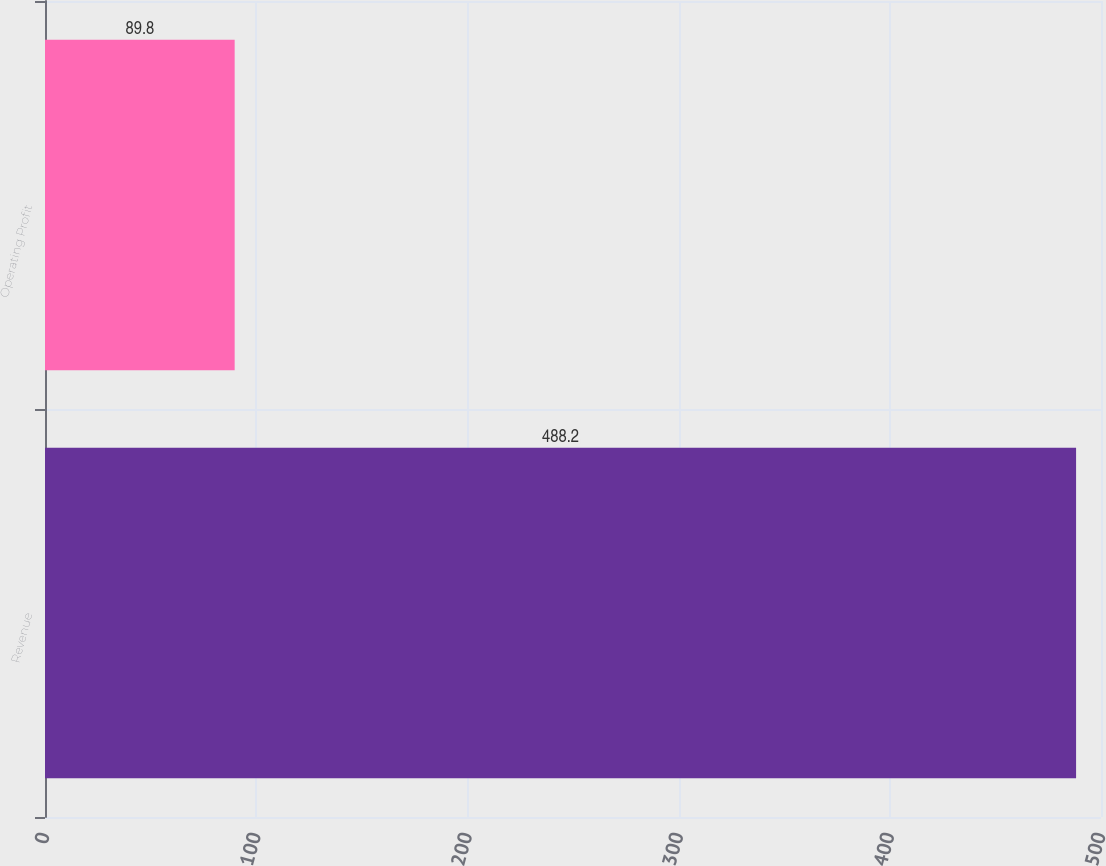Convert chart. <chart><loc_0><loc_0><loc_500><loc_500><bar_chart><fcel>Revenue<fcel>Operating Profit<nl><fcel>488.2<fcel>89.8<nl></chart> 